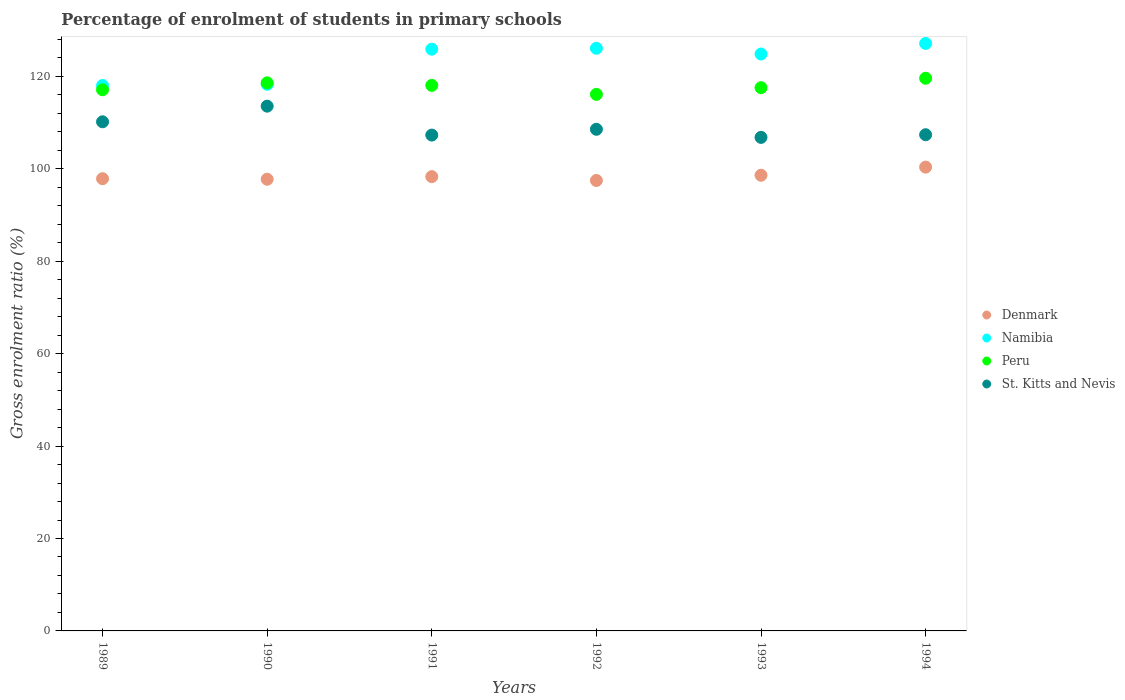How many different coloured dotlines are there?
Provide a short and direct response. 4. What is the percentage of students enrolled in primary schools in St. Kitts and Nevis in 1992?
Keep it short and to the point. 108.55. Across all years, what is the maximum percentage of students enrolled in primary schools in Peru?
Offer a terse response. 119.59. Across all years, what is the minimum percentage of students enrolled in primary schools in Namibia?
Offer a terse response. 118.03. What is the total percentage of students enrolled in primary schools in St. Kitts and Nevis in the graph?
Offer a terse response. 653.75. What is the difference between the percentage of students enrolled in primary schools in Denmark in 1993 and that in 1994?
Give a very brief answer. -1.76. What is the difference between the percentage of students enrolled in primary schools in Peru in 1989 and the percentage of students enrolled in primary schools in Denmark in 1990?
Provide a succinct answer. 19.36. What is the average percentage of students enrolled in primary schools in Peru per year?
Ensure brevity in your answer.  117.83. In the year 1993, what is the difference between the percentage of students enrolled in primary schools in St. Kitts and Nevis and percentage of students enrolled in primary schools in Denmark?
Make the answer very short. 8.19. In how many years, is the percentage of students enrolled in primary schools in St. Kitts and Nevis greater than 24 %?
Give a very brief answer. 6. What is the ratio of the percentage of students enrolled in primary schools in Peru in 1990 to that in 1994?
Keep it short and to the point. 0.99. Is the percentage of students enrolled in primary schools in Denmark in 1990 less than that in 1994?
Ensure brevity in your answer.  Yes. Is the difference between the percentage of students enrolled in primary schools in St. Kitts and Nevis in 1989 and 1993 greater than the difference between the percentage of students enrolled in primary schools in Denmark in 1989 and 1993?
Give a very brief answer. Yes. What is the difference between the highest and the second highest percentage of students enrolled in primary schools in Peru?
Offer a terse response. 0.99. What is the difference between the highest and the lowest percentage of students enrolled in primary schools in Namibia?
Provide a succinct answer. 9.1. In how many years, is the percentage of students enrolled in primary schools in St. Kitts and Nevis greater than the average percentage of students enrolled in primary schools in St. Kitts and Nevis taken over all years?
Offer a terse response. 2. Is the sum of the percentage of students enrolled in primary schools in Denmark in 1992 and 1993 greater than the maximum percentage of students enrolled in primary schools in Peru across all years?
Ensure brevity in your answer.  Yes. Is the percentage of students enrolled in primary schools in Namibia strictly greater than the percentage of students enrolled in primary schools in Denmark over the years?
Provide a short and direct response. Yes. How many years are there in the graph?
Keep it short and to the point. 6. Are the values on the major ticks of Y-axis written in scientific E-notation?
Offer a very short reply. No. Where does the legend appear in the graph?
Offer a terse response. Center right. How are the legend labels stacked?
Your response must be concise. Vertical. What is the title of the graph?
Give a very brief answer. Percentage of enrolment of students in primary schools. Does "Montenegro" appear as one of the legend labels in the graph?
Offer a very short reply. No. What is the Gross enrolment ratio (%) in Denmark in 1989?
Provide a succinct answer. 97.86. What is the Gross enrolment ratio (%) in Namibia in 1989?
Your answer should be very brief. 118.03. What is the Gross enrolment ratio (%) of Peru in 1989?
Offer a very short reply. 117.1. What is the Gross enrolment ratio (%) of St. Kitts and Nevis in 1989?
Give a very brief answer. 110.17. What is the Gross enrolment ratio (%) of Denmark in 1990?
Make the answer very short. 97.74. What is the Gross enrolment ratio (%) in Namibia in 1990?
Your response must be concise. 118.28. What is the Gross enrolment ratio (%) of Peru in 1990?
Your answer should be very brief. 118.6. What is the Gross enrolment ratio (%) in St. Kitts and Nevis in 1990?
Keep it short and to the point. 113.56. What is the Gross enrolment ratio (%) of Denmark in 1991?
Provide a succinct answer. 98.31. What is the Gross enrolment ratio (%) in Namibia in 1991?
Make the answer very short. 125.88. What is the Gross enrolment ratio (%) in Peru in 1991?
Your answer should be very brief. 118.05. What is the Gross enrolment ratio (%) in St. Kitts and Nevis in 1991?
Your answer should be very brief. 107.3. What is the Gross enrolment ratio (%) of Denmark in 1992?
Offer a very short reply. 97.48. What is the Gross enrolment ratio (%) of Namibia in 1992?
Your response must be concise. 126.08. What is the Gross enrolment ratio (%) of Peru in 1992?
Give a very brief answer. 116.1. What is the Gross enrolment ratio (%) in St. Kitts and Nevis in 1992?
Provide a short and direct response. 108.55. What is the Gross enrolment ratio (%) in Denmark in 1993?
Your answer should be compact. 98.61. What is the Gross enrolment ratio (%) of Namibia in 1993?
Make the answer very short. 124.84. What is the Gross enrolment ratio (%) of Peru in 1993?
Make the answer very short. 117.55. What is the Gross enrolment ratio (%) of St. Kitts and Nevis in 1993?
Your answer should be very brief. 106.8. What is the Gross enrolment ratio (%) in Denmark in 1994?
Offer a very short reply. 100.36. What is the Gross enrolment ratio (%) in Namibia in 1994?
Offer a terse response. 127.13. What is the Gross enrolment ratio (%) in Peru in 1994?
Offer a terse response. 119.59. What is the Gross enrolment ratio (%) in St. Kitts and Nevis in 1994?
Ensure brevity in your answer.  107.37. Across all years, what is the maximum Gross enrolment ratio (%) of Denmark?
Ensure brevity in your answer.  100.36. Across all years, what is the maximum Gross enrolment ratio (%) of Namibia?
Keep it short and to the point. 127.13. Across all years, what is the maximum Gross enrolment ratio (%) of Peru?
Ensure brevity in your answer.  119.59. Across all years, what is the maximum Gross enrolment ratio (%) of St. Kitts and Nevis?
Your answer should be compact. 113.56. Across all years, what is the minimum Gross enrolment ratio (%) in Denmark?
Provide a short and direct response. 97.48. Across all years, what is the minimum Gross enrolment ratio (%) in Namibia?
Ensure brevity in your answer.  118.03. Across all years, what is the minimum Gross enrolment ratio (%) of Peru?
Provide a short and direct response. 116.1. Across all years, what is the minimum Gross enrolment ratio (%) in St. Kitts and Nevis?
Make the answer very short. 106.8. What is the total Gross enrolment ratio (%) of Denmark in the graph?
Your answer should be very brief. 590.35. What is the total Gross enrolment ratio (%) of Namibia in the graph?
Keep it short and to the point. 740.24. What is the total Gross enrolment ratio (%) in Peru in the graph?
Ensure brevity in your answer.  707.01. What is the total Gross enrolment ratio (%) of St. Kitts and Nevis in the graph?
Make the answer very short. 653.75. What is the difference between the Gross enrolment ratio (%) in Denmark in 1989 and that in 1990?
Provide a short and direct response. 0.12. What is the difference between the Gross enrolment ratio (%) of Namibia in 1989 and that in 1990?
Your answer should be very brief. -0.25. What is the difference between the Gross enrolment ratio (%) in Peru in 1989 and that in 1990?
Give a very brief answer. -1.5. What is the difference between the Gross enrolment ratio (%) in St. Kitts and Nevis in 1989 and that in 1990?
Make the answer very short. -3.38. What is the difference between the Gross enrolment ratio (%) of Denmark in 1989 and that in 1991?
Your answer should be compact. -0.45. What is the difference between the Gross enrolment ratio (%) in Namibia in 1989 and that in 1991?
Provide a succinct answer. -7.85. What is the difference between the Gross enrolment ratio (%) in Peru in 1989 and that in 1991?
Ensure brevity in your answer.  -0.95. What is the difference between the Gross enrolment ratio (%) of St. Kitts and Nevis in 1989 and that in 1991?
Give a very brief answer. 2.88. What is the difference between the Gross enrolment ratio (%) of Denmark in 1989 and that in 1992?
Your answer should be compact. 0.38. What is the difference between the Gross enrolment ratio (%) in Namibia in 1989 and that in 1992?
Keep it short and to the point. -8.05. What is the difference between the Gross enrolment ratio (%) in Peru in 1989 and that in 1992?
Provide a short and direct response. 1. What is the difference between the Gross enrolment ratio (%) in St. Kitts and Nevis in 1989 and that in 1992?
Ensure brevity in your answer.  1.62. What is the difference between the Gross enrolment ratio (%) in Denmark in 1989 and that in 1993?
Your answer should be very brief. -0.75. What is the difference between the Gross enrolment ratio (%) of Namibia in 1989 and that in 1993?
Your answer should be very brief. -6.81. What is the difference between the Gross enrolment ratio (%) of Peru in 1989 and that in 1993?
Offer a very short reply. -0.45. What is the difference between the Gross enrolment ratio (%) in St. Kitts and Nevis in 1989 and that in 1993?
Offer a very short reply. 3.37. What is the difference between the Gross enrolment ratio (%) of Denmark in 1989 and that in 1994?
Make the answer very short. -2.51. What is the difference between the Gross enrolment ratio (%) in Namibia in 1989 and that in 1994?
Provide a short and direct response. -9.1. What is the difference between the Gross enrolment ratio (%) in Peru in 1989 and that in 1994?
Provide a succinct answer. -2.49. What is the difference between the Gross enrolment ratio (%) of St. Kitts and Nevis in 1989 and that in 1994?
Make the answer very short. 2.8. What is the difference between the Gross enrolment ratio (%) in Denmark in 1990 and that in 1991?
Give a very brief answer. -0.57. What is the difference between the Gross enrolment ratio (%) in Namibia in 1990 and that in 1991?
Provide a short and direct response. -7.6. What is the difference between the Gross enrolment ratio (%) in Peru in 1990 and that in 1991?
Provide a short and direct response. 0.55. What is the difference between the Gross enrolment ratio (%) in St. Kitts and Nevis in 1990 and that in 1991?
Your answer should be very brief. 6.26. What is the difference between the Gross enrolment ratio (%) in Denmark in 1990 and that in 1992?
Provide a short and direct response. 0.27. What is the difference between the Gross enrolment ratio (%) in Namibia in 1990 and that in 1992?
Offer a terse response. -7.79. What is the difference between the Gross enrolment ratio (%) in Peru in 1990 and that in 1992?
Offer a terse response. 2.5. What is the difference between the Gross enrolment ratio (%) in St. Kitts and Nevis in 1990 and that in 1992?
Your response must be concise. 5. What is the difference between the Gross enrolment ratio (%) in Denmark in 1990 and that in 1993?
Ensure brevity in your answer.  -0.87. What is the difference between the Gross enrolment ratio (%) of Namibia in 1990 and that in 1993?
Your response must be concise. -6.56. What is the difference between the Gross enrolment ratio (%) of Peru in 1990 and that in 1993?
Offer a very short reply. 1.05. What is the difference between the Gross enrolment ratio (%) in St. Kitts and Nevis in 1990 and that in 1993?
Your answer should be very brief. 6.76. What is the difference between the Gross enrolment ratio (%) of Denmark in 1990 and that in 1994?
Your response must be concise. -2.62. What is the difference between the Gross enrolment ratio (%) of Namibia in 1990 and that in 1994?
Give a very brief answer. -8.85. What is the difference between the Gross enrolment ratio (%) in Peru in 1990 and that in 1994?
Offer a very short reply. -0.99. What is the difference between the Gross enrolment ratio (%) in St. Kitts and Nevis in 1990 and that in 1994?
Ensure brevity in your answer.  6.18. What is the difference between the Gross enrolment ratio (%) in Denmark in 1991 and that in 1992?
Offer a very short reply. 0.83. What is the difference between the Gross enrolment ratio (%) in Namibia in 1991 and that in 1992?
Give a very brief answer. -0.2. What is the difference between the Gross enrolment ratio (%) in Peru in 1991 and that in 1992?
Provide a short and direct response. 1.95. What is the difference between the Gross enrolment ratio (%) of St. Kitts and Nevis in 1991 and that in 1992?
Your answer should be compact. -1.25. What is the difference between the Gross enrolment ratio (%) in Namibia in 1991 and that in 1993?
Your answer should be compact. 1.04. What is the difference between the Gross enrolment ratio (%) in Peru in 1991 and that in 1993?
Your answer should be very brief. 0.5. What is the difference between the Gross enrolment ratio (%) of St. Kitts and Nevis in 1991 and that in 1993?
Provide a short and direct response. 0.5. What is the difference between the Gross enrolment ratio (%) in Denmark in 1991 and that in 1994?
Your answer should be compact. -2.06. What is the difference between the Gross enrolment ratio (%) of Namibia in 1991 and that in 1994?
Your answer should be very brief. -1.25. What is the difference between the Gross enrolment ratio (%) in Peru in 1991 and that in 1994?
Offer a terse response. -1.54. What is the difference between the Gross enrolment ratio (%) in St. Kitts and Nevis in 1991 and that in 1994?
Keep it short and to the point. -0.08. What is the difference between the Gross enrolment ratio (%) in Denmark in 1992 and that in 1993?
Offer a terse response. -1.13. What is the difference between the Gross enrolment ratio (%) of Namibia in 1992 and that in 1993?
Make the answer very short. 1.24. What is the difference between the Gross enrolment ratio (%) in Peru in 1992 and that in 1993?
Provide a succinct answer. -1.45. What is the difference between the Gross enrolment ratio (%) in St. Kitts and Nevis in 1992 and that in 1993?
Offer a very short reply. 1.75. What is the difference between the Gross enrolment ratio (%) in Denmark in 1992 and that in 1994?
Provide a short and direct response. -2.89. What is the difference between the Gross enrolment ratio (%) in Namibia in 1992 and that in 1994?
Offer a very short reply. -1.05. What is the difference between the Gross enrolment ratio (%) of Peru in 1992 and that in 1994?
Provide a short and direct response. -3.49. What is the difference between the Gross enrolment ratio (%) in St. Kitts and Nevis in 1992 and that in 1994?
Ensure brevity in your answer.  1.18. What is the difference between the Gross enrolment ratio (%) in Denmark in 1993 and that in 1994?
Provide a short and direct response. -1.76. What is the difference between the Gross enrolment ratio (%) in Namibia in 1993 and that in 1994?
Keep it short and to the point. -2.29. What is the difference between the Gross enrolment ratio (%) of Peru in 1993 and that in 1994?
Offer a terse response. -2.04. What is the difference between the Gross enrolment ratio (%) in St. Kitts and Nevis in 1993 and that in 1994?
Your response must be concise. -0.57. What is the difference between the Gross enrolment ratio (%) in Denmark in 1989 and the Gross enrolment ratio (%) in Namibia in 1990?
Provide a succinct answer. -20.43. What is the difference between the Gross enrolment ratio (%) in Denmark in 1989 and the Gross enrolment ratio (%) in Peru in 1990?
Your response must be concise. -20.74. What is the difference between the Gross enrolment ratio (%) in Denmark in 1989 and the Gross enrolment ratio (%) in St. Kitts and Nevis in 1990?
Your answer should be very brief. -15.7. What is the difference between the Gross enrolment ratio (%) of Namibia in 1989 and the Gross enrolment ratio (%) of Peru in 1990?
Give a very brief answer. -0.57. What is the difference between the Gross enrolment ratio (%) of Namibia in 1989 and the Gross enrolment ratio (%) of St. Kitts and Nevis in 1990?
Your response must be concise. 4.47. What is the difference between the Gross enrolment ratio (%) in Peru in 1989 and the Gross enrolment ratio (%) in St. Kitts and Nevis in 1990?
Keep it short and to the point. 3.55. What is the difference between the Gross enrolment ratio (%) of Denmark in 1989 and the Gross enrolment ratio (%) of Namibia in 1991?
Offer a terse response. -28.03. What is the difference between the Gross enrolment ratio (%) of Denmark in 1989 and the Gross enrolment ratio (%) of Peru in 1991?
Ensure brevity in your answer.  -20.19. What is the difference between the Gross enrolment ratio (%) of Denmark in 1989 and the Gross enrolment ratio (%) of St. Kitts and Nevis in 1991?
Provide a succinct answer. -9.44. What is the difference between the Gross enrolment ratio (%) in Namibia in 1989 and the Gross enrolment ratio (%) in Peru in 1991?
Provide a succinct answer. -0.02. What is the difference between the Gross enrolment ratio (%) of Namibia in 1989 and the Gross enrolment ratio (%) of St. Kitts and Nevis in 1991?
Keep it short and to the point. 10.73. What is the difference between the Gross enrolment ratio (%) in Peru in 1989 and the Gross enrolment ratio (%) in St. Kitts and Nevis in 1991?
Ensure brevity in your answer.  9.81. What is the difference between the Gross enrolment ratio (%) in Denmark in 1989 and the Gross enrolment ratio (%) in Namibia in 1992?
Your answer should be compact. -28.22. What is the difference between the Gross enrolment ratio (%) in Denmark in 1989 and the Gross enrolment ratio (%) in Peru in 1992?
Provide a short and direct response. -18.25. What is the difference between the Gross enrolment ratio (%) in Denmark in 1989 and the Gross enrolment ratio (%) in St. Kitts and Nevis in 1992?
Ensure brevity in your answer.  -10.69. What is the difference between the Gross enrolment ratio (%) of Namibia in 1989 and the Gross enrolment ratio (%) of Peru in 1992?
Your answer should be very brief. 1.92. What is the difference between the Gross enrolment ratio (%) in Namibia in 1989 and the Gross enrolment ratio (%) in St. Kitts and Nevis in 1992?
Provide a succinct answer. 9.48. What is the difference between the Gross enrolment ratio (%) in Peru in 1989 and the Gross enrolment ratio (%) in St. Kitts and Nevis in 1992?
Provide a succinct answer. 8.55. What is the difference between the Gross enrolment ratio (%) of Denmark in 1989 and the Gross enrolment ratio (%) of Namibia in 1993?
Your answer should be very brief. -26.98. What is the difference between the Gross enrolment ratio (%) in Denmark in 1989 and the Gross enrolment ratio (%) in Peru in 1993?
Your answer should be compact. -19.7. What is the difference between the Gross enrolment ratio (%) of Denmark in 1989 and the Gross enrolment ratio (%) of St. Kitts and Nevis in 1993?
Your answer should be compact. -8.94. What is the difference between the Gross enrolment ratio (%) of Namibia in 1989 and the Gross enrolment ratio (%) of Peru in 1993?
Provide a succinct answer. 0.47. What is the difference between the Gross enrolment ratio (%) in Namibia in 1989 and the Gross enrolment ratio (%) in St. Kitts and Nevis in 1993?
Provide a succinct answer. 11.23. What is the difference between the Gross enrolment ratio (%) of Peru in 1989 and the Gross enrolment ratio (%) of St. Kitts and Nevis in 1993?
Provide a short and direct response. 10.3. What is the difference between the Gross enrolment ratio (%) in Denmark in 1989 and the Gross enrolment ratio (%) in Namibia in 1994?
Provide a short and direct response. -29.27. What is the difference between the Gross enrolment ratio (%) of Denmark in 1989 and the Gross enrolment ratio (%) of Peru in 1994?
Ensure brevity in your answer.  -21.74. What is the difference between the Gross enrolment ratio (%) of Denmark in 1989 and the Gross enrolment ratio (%) of St. Kitts and Nevis in 1994?
Offer a terse response. -9.52. What is the difference between the Gross enrolment ratio (%) of Namibia in 1989 and the Gross enrolment ratio (%) of Peru in 1994?
Offer a terse response. -1.56. What is the difference between the Gross enrolment ratio (%) in Namibia in 1989 and the Gross enrolment ratio (%) in St. Kitts and Nevis in 1994?
Your response must be concise. 10.66. What is the difference between the Gross enrolment ratio (%) in Peru in 1989 and the Gross enrolment ratio (%) in St. Kitts and Nevis in 1994?
Your answer should be very brief. 9.73. What is the difference between the Gross enrolment ratio (%) in Denmark in 1990 and the Gross enrolment ratio (%) in Namibia in 1991?
Offer a very short reply. -28.14. What is the difference between the Gross enrolment ratio (%) in Denmark in 1990 and the Gross enrolment ratio (%) in Peru in 1991?
Offer a very short reply. -20.31. What is the difference between the Gross enrolment ratio (%) in Denmark in 1990 and the Gross enrolment ratio (%) in St. Kitts and Nevis in 1991?
Offer a terse response. -9.56. What is the difference between the Gross enrolment ratio (%) in Namibia in 1990 and the Gross enrolment ratio (%) in Peru in 1991?
Offer a very short reply. 0.23. What is the difference between the Gross enrolment ratio (%) in Namibia in 1990 and the Gross enrolment ratio (%) in St. Kitts and Nevis in 1991?
Your response must be concise. 10.99. What is the difference between the Gross enrolment ratio (%) in Peru in 1990 and the Gross enrolment ratio (%) in St. Kitts and Nevis in 1991?
Keep it short and to the point. 11.3. What is the difference between the Gross enrolment ratio (%) in Denmark in 1990 and the Gross enrolment ratio (%) in Namibia in 1992?
Offer a very short reply. -28.34. What is the difference between the Gross enrolment ratio (%) of Denmark in 1990 and the Gross enrolment ratio (%) of Peru in 1992?
Ensure brevity in your answer.  -18.36. What is the difference between the Gross enrolment ratio (%) in Denmark in 1990 and the Gross enrolment ratio (%) in St. Kitts and Nevis in 1992?
Provide a short and direct response. -10.81. What is the difference between the Gross enrolment ratio (%) of Namibia in 1990 and the Gross enrolment ratio (%) of Peru in 1992?
Your answer should be very brief. 2.18. What is the difference between the Gross enrolment ratio (%) in Namibia in 1990 and the Gross enrolment ratio (%) in St. Kitts and Nevis in 1992?
Ensure brevity in your answer.  9.73. What is the difference between the Gross enrolment ratio (%) of Peru in 1990 and the Gross enrolment ratio (%) of St. Kitts and Nevis in 1992?
Provide a short and direct response. 10.05. What is the difference between the Gross enrolment ratio (%) of Denmark in 1990 and the Gross enrolment ratio (%) of Namibia in 1993?
Your answer should be compact. -27.1. What is the difference between the Gross enrolment ratio (%) of Denmark in 1990 and the Gross enrolment ratio (%) of Peru in 1993?
Offer a terse response. -19.81. What is the difference between the Gross enrolment ratio (%) of Denmark in 1990 and the Gross enrolment ratio (%) of St. Kitts and Nevis in 1993?
Your answer should be very brief. -9.06. What is the difference between the Gross enrolment ratio (%) of Namibia in 1990 and the Gross enrolment ratio (%) of Peru in 1993?
Your response must be concise. 0.73. What is the difference between the Gross enrolment ratio (%) in Namibia in 1990 and the Gross enrolment ratio (%) in St. Kitts and Nevis in 1993?
Your answer should be compact. 11.48. What is the difference between the Gross enrolment ratio (%) of Peru in 1990 and the Gross enrolment ratio (%) of St. Kitts and Nevis in 1993?
Give a very brief answer. 11.8. What is the difference between the Gross enrolment ratio (%) in Denmark in 1990 and the Gross enrolment ratio (%) in Namibia in 1994?
Keep it short and to the point. -29.39. What is the difference between the Gross enrolment ratio (%) of Denmark in 1990 and the Gross enrolment ratio (%) of Peru in 1994?
Give a very brief answer. -21.85. What is the difference between the Gross enrolment ratio (%) in Denmark in 1990 and the Gross enrolment ratio (%) in St. Kitts and Nevis in 1994?
Give a very brief answer. -9.63. What is the difference between the Gross enrolment ratio (%) of Namibia in 1990 and the Gross enrolment ratio (%) of Peru in 1994?
Your answer should be compact. -1.31. What is the difference between the Gross enrolment ratio (%) in Namibia in 1990 and the Gross enrolment ratio (%) in St. Kitts and Nevis in 1994?
Ensure brevity in your answer.  10.91. What is the difference between the Gross enrolment ratio (%) of Peru in 1990 and the Gross enrolment ratio (%) of St. Kitts and Nevis in 1994?
Give a very brief answer. 11.23. What is the difference between the Gross enrolment ratio (%) of Denmark in 1991 and the Gross enrolment ratio (%) of Namibia in 1992?
Provide a succinct answer. -27.77. What is the difference between the Gross enrolment ratio (%) in Denmark in 1991 and the Gross enrolment ratio (%) in Peru in 1992?
Your response must be concise. -17.8. What is the difference between the Gross enrolment ratio (%) of Denmark in 1991 and the Gross enrolment ratio (%) of St. Kitts and Nevis in 1992?
Provide a short and direct response. -10.24. What is the difference between the Gross enrolment ratio (%) in Namibia in 1991 and the Gross enrolment ratio (%) in Peru in 1992?
Your answer should be compact. 9.78. What is the difference between the Gross enrolment ratio (%) in Namibia in 1991 and the Gross enrolment ratio (%) in St. Kitts and Nevis in 1992?
Your answer should be compact. 17.33. What is the difference between the Gross enrolment ratio (%) of Peru in 1991 and the Gross enrolment ratio (%) of St. Kitts and Nevis in 1992?
Offer a very short reply. 9.5. What is the difference between the Gross enrolment ratio (%) of Denmark in 1991 and the Gross enrolment ratio (%) of Namibia in 1993?
Offer a very short reply. -26.53. What is the difference between the Gross enrolment ratio (%) in Denmark in 1991 and the Gross enrolment ratio (%) in Peru in 1993?
Your answer should be very brief. -19.25. What is the difference between the Gross enrolment ratio (%) in Denmark in 1991 and the Gross enrolment ratio (%) in St. Kitts and Nevis in 1993?
Provide a short and direct response. -8.49. What is the difference between the Gross enrolment ratio (%) of Namibia in 1991 and the Gross enrolment ratio (%) of Peru in 1993?
Your answer should be compact. 8.33. What is the difference between the Gross enrolment ratio (%) in Namibia in 1991 and the Gross enrolment ratio (%) in St. Kitts and Nevis in 1993?
Offer a terse response. 19.08. What is the difference between the Gross enrolment ratio (%) in Peru in 1991 and the Gross enrolment ratio (%) in St. Kitts and Nevis in 1993?
Make the answer very short. 11.25. What is the difference between the Gross enrolment ratio (%) of Denmark in 1991 and the Gross enrolment ratio (%) of Namibia in 1994?
Your response must be concise. -28.82. What is the difference between the Gross enrolment ratio (%) in Denmark in 1991 and the Gross enrolment ratio (%) in Peru in 1994?
Offer a terse response. -21.29. What is the difference between the Gross enrolment ratio (%) in Denmark in 1991 and the Gross enrolment ratio (%) in St. Kitts and Nevis in 1994?
Your answer should be compact. -9.07. What is the difference between the Gross enrolment ratio (%) in Namibia in 1991 and the Gross enrolment ratio (%) in Peru in 1994?
Provide a succinct answer. 6.29. What is the difference between the Gross enrolment ratio (%) of Namibia in 1991 and the Gross enrolment ratio (%) of St. Kitts and Nevis in 1994?
Keep it short and to the point. 18.51. What is the difference between the Gross enrolment ratio (%) in Peru in 1991 and the Gross enrolment ratio (%) in St. Kitts and Nevis in 1994?
Your answer should be compact. 10.68. What is the difference between the Gross enrolment ratio (%) in Denmark in 1992 and the Gross enrolment ratio (%) in Namibia in 1993?
Your answer should be compact. -27.36. What is the difference between the Gross enrolment ratio (%) of Denmark in 1992 and the Gross enrolment ratio (%) of Peru in 1993?
Your answer should be very brief. -20.08. What is the difference between the Gross enrolment ratio (%) of Denmark in 1992 and the Gross enrolment ratio (%) of St. Kitts and Nevis in 1993?
Your answer should be very brief. -9.32. What is the difference between the Gross enrolment ratio (%) of Namibia in 1992 and the Gross enrolment ratio (%) of Peru in 1993?
Give a very brief answer. 8.52. What is the difference between the Gross enrolment ratio (%) in Namibia in 1992 and the Gross enrolment ratio (%) in St. Kitts and Nevis in 1993?
Your answer should be compact. 19.28. What is the difference between the Gross enrolment ratio (%) in Peru in 1992 and the Gross enrolment ratio (%) in St. Kitts and Nevis in 1993?
Provide a short and direct response. 9.3. What is the difference between the Gross enrolment ratio (%) of Denmark in 1992 and the Gross enrolment ratio (%) of Namibia in 1994?
Offer a terse response. -29.66. What is the difference between the Gross enrolment ratio (%) in Denmark in 1992 and the Gross enrolment ratio (%) in Peru in 1994?
Give a very brief answer. -22.12. What is the difference between the Gross enrolment ratio (%) of Denmark in 1992 and the Gross enrolment ratio (%) of St. Kitts and Nevis in 1994?
Your answer should be very brief. -9.9. What is the difference between the Gross enrolment ratio (%) in Namibia in 1992 and the Gross enrolment ratio (%) in Peru in 1994?
Provide a succinct answer. 6.48. What is the difference between the Gross enrolment ratio (%) of Namibia in 1992 and the Gross enrolment ratio (%) of St. Kitts and Nevis in 1994?
Ensure brevity in your answer.  18.7. What is the difference between the Gross enrolment ratio (%) in Peru in 1992 and the Gross enrolment ratio (%) in St. Kitts and Nevis in 1994?
Your response must be concise. 8.73. What is the difference between the Gross enrolment ratio (%) in Denmark in 1993 and the Gross enrolment ratio (%) in Namibia in 1994?
Offer a very short reply. -28.52. What is the difference between the Gross enrolment ratio (%) of Denmark in 1993 and the Gross enrolment ratio (%) of Peru in 1994?
Keep it short and to the point. -20.99. What is the difference between the Gross enrolment ratio (%) of Denmark in 1993 and the Gross enrolment ratio (%) of St. Kitts and Nevis in 1994?
Offer a terse response. -8.77. What is the difference between the Gross enrolment ratio (%) in Namibia in 1993 and the Gross enrolment ratio (%) in Peru in 1994?
Ensure brevity in your answer.  5.25. What is the difference between the Gross enrolment ratio (%) of Namibia in 1993 and the Gross enrolment ratio (%) of St. Kitts and Nevis in 1994?
Provide a short and direct response. 17.47. What is the difference between the Gross enrolment ratio (%) in Peru in 1993 and the Gross enrolment ratio (%) in St. Kitts and Nevis in 1994?
Your response must be concise. 10.18. What is the average Gross enrolment ratio (%) of Denmark per year?
Offer a terse response. 98.39. What is the average Gross enrolment ratio (%) in Namibia per year?
Make the answer very short. 123.37. What is the average Gross enrolment ratio (%) of Peru per year?
Ensure brevity in your answer.  117.83. What is the average Gross enrolment ratio (%) in St. Kitts and Nevis per year?
Keep it short and to the point. 108.96. In the year 1989, what is the difference between the Gross enrolment ratio (%) in Denmark and Gross enrolment ratio (%) in Namibia?
Your response must be concise. -20.17. In the year 1989, what is the difference between the Gross enrolment ratio (%) in Denmark and Gross enrolment ratio (%) in Peru?
Give a very brief answer. -19.25. In the year 1989, what is the difference between the Gross enrolment ratio (%) of Denmark and Gross enrolment ratio (%) of St. Kitts and Nevis?
Offer a very short reply. -12.32. In the year 1989, what is the difference between the Gross enrolment ratio (%) of Namibia and Gross enrolment ratio (%) of Peru?
Your answer should be very brief. 0.92. In the year 1989, what is the difference between the Gross enrolment ratio (%) in Namibia and Gross enrolment ratio (%) in St. Kitts and Nevis?
Provide a succinct answer. 7.86. In the year 1989, what is the difference between the Gross enrolment ratio (%) of Peru and Gross enrolment ratio (%) of St. Kitts and Nevis?
Your response must be concise. 6.93. In the year 1990, what is the difference between the Gross enrolment ratio (%) of Denmark and Gross enrolment ratio (%) of Namibia?
Your response must be concise. -20.54. In the year 1990, what is the difference between the Gross enrolment ratio (%) in Denmark and Gross enrolment ratio (%) in Peru?
Ensure brevity in your answer.  -20.86. In the year 1990, what is the difference between the Gross enrolment ratio (%) in Denmark and Gross enrolment ratio (%) in St. Kitts and Nevis?
Keep it short and to the point. -15.81. In the year 1990, what is the difference between the Gross enrolment ratio (%) in Namibia and Gross enrolment ratio (%) in Peru?
Make the answer very short. -0.32. In the year 1990, what is the difference between the Gross enrolment ratio (%) in Namibia and Gross enrolment ratio (%) in St. Kitts and Nevis?
Make the answer very short. 4.73. In the year 1990, what is the difference between the Gross enrolment ratio (%) of Peru and Gross enrolment ratio (%) of St. Kitts and Nevis?
Offer a very short reply. 5.05. In the year 1991, what is the difference between the Gross enrolment ratio (%) in Denmark and Gross enrolment ratio (%) in Namibia?
Give a very brief answer. -27.58. In the year 1991, what is the difference between the Gross enrolment ratio (%) of Denmark and Gross enrolment ratio (%) of Peru?
Keep it short and to the point. -19.74. In the year 1991, what is the difference between the Gross enrolment ratio (%) in Denmark and Gross enrolment ratio (%) in St. Kitts and Nevis?
Your answer should be very brief. -8.99. In the year 1991, what is the difference between the Gross enrolment ratio (%) in Namibia and Gross enrolment ratio (%) in Peru?
Give a very brief answer. 7.83. In the year 1991, what is the difference between the Gross enrolment ratio (%) of Namibia and Gross enrolment ratio (%) of St. Kitts and Nevis?
Your answer should be compact. 18.59. In the year 1991, what is the difference between the Gross enrolment ratio (%) in Peru and Gross enrolment ratio (%) in St. Kitts and Nevis?
Offer a very short reply. 10.75. In the year 1992, what is the difference between the Gross enrolment ratio (%) in Denmark and Gross enrolment ratio (%) in Namibia?
Your answer should be compact. -28.6. In the year 1992, what is the difference between the Gross enrolment ratio (%) of Denmark and Gross enrolment ratio (%) of Peru?
Make the answer very short. -18.63. In the year 1992, what is the difference between the Gross enrolment ratio (%) in Denmark and Gross enrolment ratio (%) in St. Kitts and Nevis?
Offer a very short reply. -11.08. In the year 1992, what is the difference between the Gross enrolment ratio (%) of Namibia and Gross enrolment ratio (%) of Peru?
Your response must be concise. 9.97. In the year 1992, what is the difference between the Gross enrolment ratio (%) in Namibia and Gross enrolment ratio (%) in St. Kitts and Nevis?
Provide a succinct answer. 17.53. In the year 1992, what is the difference between the Gross enrolment ratio (%) in Peru and Gross enrolment ratio (%) in St. Kitts and Nevis?
Your answer should be compact. 7.55. In the year 1993, what is the difference between the Gross enrolment ratio (%) of Denmark and Gross enrolment ratio (%) of Namibia?
Provide a short and direct response. -26.23. In the year 1993, what is the difference between the Gross enrolment ratio (%) of Denmark and Gross enrolment ratio (%) of Peru?
Ensure brevity in your answer.  -18.95. In the year 1993, what is the difference between the Gross enrolment ratio (%) of Denmark and Gross enrolment ratio (%) of St. Kitts and Nevis?
Offer a very short reply. -8.19. In the year 1993, what is the difference between the Gross enrolment ratio (%) of Namibia and Gross enrolment ratio (%) of Peru?
Keep it short and to the point. 7.28. In the year 1993, what is the difference between the Gross enrolment ratio (%) in Namibia and Gross enrolment ratio (%) in St. Kitts and Nevis?
Offer a very short reply. 18.04. In the year 1993, what is the difference between the Gross enrolment ratio (%) in Peru and Gross enrolment ratio (%) in St. Kitts and Nevis?
Offer a terse response. 10.76. In the year 1994, what is the difference between the Gross enrolment ratio (%) of Denmark and Gross enrolment ratio (%) of Namibia?
Your response must be concise. -26.77. In the year 1994, what is the difference between the Gross enrolment ratio (%) of Denmark and Gross enrolment ratio (%) of Peru?
Your answer should be very brief. -19.23. In the year 1994, what is the difference between the Gross enrolment ratio (%) of Denmark and Gross enrolment ratio (%) of St. Kitts and Nevis?
Your answer should be very brief. -7.01. In the year 1994, what is the difference between the Gross enrolment ratio (%) in Namibia and Gross enrolment ratio (%) in Peru?
Make the answer very short. 7.54. In the year 1994, what is the difference between the Gross enrolment ratio (%) of Namibia and Gross enrolment ratio (%) of St. Kitts and Nevis?
Your answer should be very brief. 19.76. In the year 1994, what is the difference between the Gross enrolment ratio (%) in Peru and Gross enrolment ratio (%) in St. Kitts and Nevis?
Keep it short and to the point. 12.22. What is the ratio of the Gross enrolment ratio (%) in Namibia in 1989 to that in 1990?
Make the answer very short. 1. What is the ratio of the Gross enrolment ratio (%) in Peru in 1989 to that in 1990?
Provide a short and direct response. 0.99. What is the ratio of the Gross enrolment ratio (%) of St. Kitts and Nevis in 1989 to that in 1990?
Provide a succinct answer. 0.97. What is the ratio of the Gross enrolment ratio (%) of Namibia in 1989 to that in 1991?
Make the answer very short. 0.94. What is the ratio of the Gross enrolment ratio (%) of St. Kitts and Nevis in 1989 to that in 1991?
Your answer should be compact. 1.03. What is the ratio of the Gross enrolment ratio (%) of Denmark in 1989 to that in 1992?
Your answer should be very brief. 1. What is the ratio of the Gross enrolment ratio (%) in Namibia in 1989 to that in 1992?
Make the answer very short. 0.94. What is the ratio of the Gross enrolment ratio (%) in Peru in 1989 to that in 1992?
Provide a succinct answer. 1.01. What is the ratio of the Gross enrolment ratio (%) in St. Kitts and Nevis in 1989 to that in 1992?
Your response must be concise. 1.01. What is the ratio of the Gross enrolment ratio (%) of Namibia in 1989 to that in 1993?
Provide a short and direct response. 0.95. What is the ratio of the Gross enrolment ratio (%) in St. Kitts and Nevis in 1989 to that in 1993?
Your answer should be very brief. 1.03. What is the ratio of the Gross enrolment ratio (%) in Denmark in 1989 to that in 1994?
Your answer should be compact. 0.97. What is the ratio of the Gross enrolment ratio (%) in Namibia in 1989 to that in 1994?
Your answer should be compact. 0.93. What is the ratio of the Gross enrolment ratio (%) of Peru in 1989 to that in 1994?
Offer a terse response. 0.98. What is the ratio of the Gross enrolment ratio (%) in St. Kitts and Nevis in 1989 to that in 1994?
Keep it short and to the point. 1.03. What is the ratio of the Gross enrolment ratio (%) in Denmark in 1990 to that in 1991?
Give a very brief answer. 0.99. What is the ratio of the Gross enrolment ratio (%) in Namibia in 1990 to that in 1991?
Your response must be concise. 0.94. What is the ratio of the Gross enrolment ratio (%) in Peru in 1990 to that in 1991?
Ensure brevity in your answer.  1. What is the ratio of the Gross enrolment ratio (%) in St. Kitts and Nevis in 1990 to that in 1991?
Your answer should be compact. 1.06. What is the ratio of the Gross enrolment ratio (%) of Namibia in 1990 to that in 1992?
Your response must be concise. 0.94. What is the ratio of the Gross enrolment ratio (%) of Peru in 1990 to that in 1992?
Make the answer very short. 1.02. What is the ratio of the Gross enrolment ratio (%) of St. Kitts and Nevis in 1990 to that in 1992?
Your answer should be compact. 1.05. What is the ratio of the Gross enrolment ratio (%) of Namibia in 1990 to that in 1993?
Your response must be concise. 0.95. What is the ratio of the Gross enrolment ratio (%) of Peru in 1990 to that in 1993?
Your answer should be very brief. 1.01. What is the ratio of the Gross enrolment ratio (%) of St. Kitts and Nevis in 1990 to that in 1993?
Provide a short and direct response. 1.06. What is the ratio of the Gross enrolment ratio (%) in Denmark in 1990 to that in 1994?
Give a very brief answer. 0.97. What is the ratio of the Gross enrolment ratio (%) in Namibia in 1990 to that in 1994?
Give a very brief answer. 0.93. What is the ratio of the Gross enrolment ratio (%) of St. Kitts and Nevis in 1990 to that in 1994?
Ensure brevity in your answer.  1.06. What is the ratio of the Gross enrolment ratio (%) of Denmark in 1991 to that in 1992?
Offer a very short reply. 1.01. What is the ratio of the Gross enrolment ratio (%) of Peru in 1991 to that in 1992?
Your response must be concise. 1.02. What is the ratio of the Gross enrolment ratio (%) in St. Kitts and Nevis in 1991 to that in 1992?
Your answer should be compact. 0.99. What is the ratio of the Gross enrolment ratio (%) of Namibia in 1991 to that in 1993?
Provide a succinct answer. 1.01. What is the ratio of the Gross enrolment ratio (%) in Peru in 1991 to that in 1993?
Make the answer very short. 1. What is the ratio of the Gross enrolment ratio (%) of St. Kitts and Nevis in 1991 to that in 1993?
Provide a succinct answer. 1. What is the ratio of the Gross enrolment ratio (%) in Denmark in 1991 to that in 1994?
Ensure brevity in your answer.  0.98. What is the ratio of the Gross enrolment ratio (%) in Namibia in 1991 to that in 1994?
Give a very brief answer. 0.99. What is the ratio of the Gross enrolment ratio (%) in Peru in 1991 to that in 1994?
Make the answer very short. 0.99. What is the ratio of the Gross enrolment ratio (%) in St. Kitts and Nevis in 1991 to that in 1994?
Give a very brief answer. 1. What is the ratio of the Gross enrolment ratio (%) in Denmark in 1992 to that in 1993?
Provide a succinct answer. 0.99. What is the ratio of the Gross enrolment ratio (%) of Namibia in 1992 to that in 1993?
Offer a very short reply. 1.01. What is the ratio of the Gross enrolment ratio (%) in Peru in 1992 to that in 1993?
Offer a terse response. 0.99. What is the ratio of the Gross enrolment ratio (%) in St. Kitts and Nevis in 1992 to that in 1993?
Ensure brevity in your answer.  1.02. What is the ratio of the Gross enrolment ratio (%) in Denmark in 1992 to that in 1994?
Provide a succinct answer. 0.97. What is the ratio of the Gross enrolment ratio (%) in Namibia in 1992 to that in 1994?
Ensure brevity in your answer.  0.99. What is the ratio of the Gross enrolment ratio (%) of Peru in 1992 to that in 1994?
Give a very brief answer. 0.97. What is the ratio of the Gross enrolment ratio (%) of Denmark in 1993 to that in 1994?
Your response must be concise. 0.98. What is the ratio of the Gross enrolment ratio (%) in Namibia in 1993 to that in 1994?
Give a very brief answer. 0.98. What is the ratio of the Gross enrolment ratio (%) in Peru in 1993 to that in 1994?
Keep it short and to the point. 0.98. What is the difference between the highest and the second highest Gross enrolment ratio (%) in Denmark?
Your response must be concise. 1.76. What is the difference between the highest and the second highest Gross enrolment ratio (%) of Namibia?
Offer a very short reply. 1.05. What is the difference between the highest and the second highest Gross enrolment ratio (%) of St. Kitts and Nevis?
Offer a very short reply. 3.38. What is the difference between the highest and the lowest Gross enrolment ratio (%) of Denmark?
Provide a short and direct response. 2.89. What is the difference between the highest and the lowest Gross enrolment ratio (%) in Namibia?
Your answer should be compact. 9.1. What is the difference between the highest and the lowest Gross enrolment ratio (%) of Peru?
Provide a short and direct response. 3.49. What is the difference between the highest and the lowest Gross enrolment ratio (%) of St. Kitts and Nevis?
Your response must be concise. 6.76. 